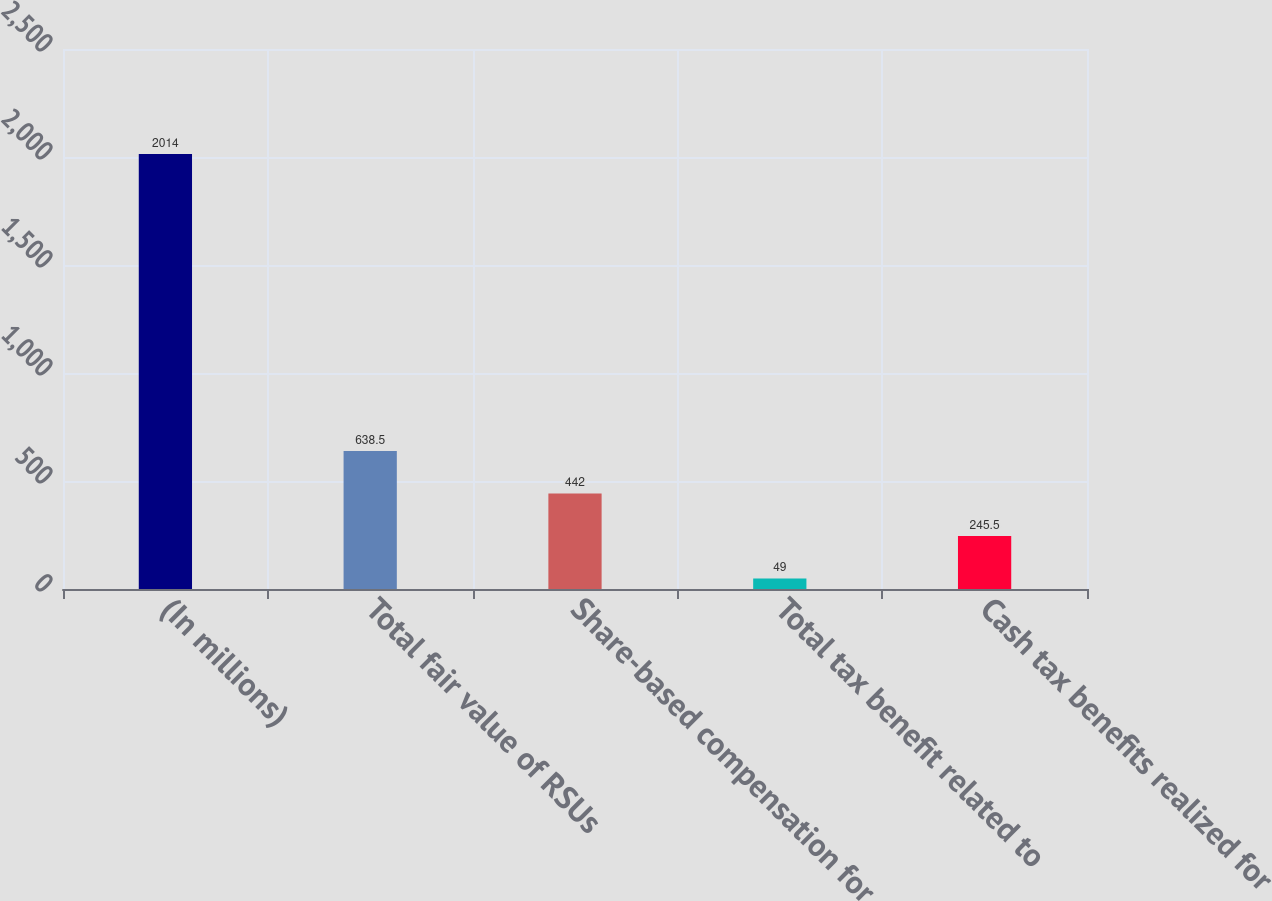Convert chart. <chart><loc_0><loc_0><loc_500><loc_500><bar_chart><fcel>(In millions)<fcel>Total fair value of RSUs<fcel>Share-based compensation for<fcel>Total tax benefit related to<fcel>Cash tax benefits realized for<nl><fcel>2014<fcel>638.5<fcel>442<fcel>49<fcel>245.5<nl></chart> 